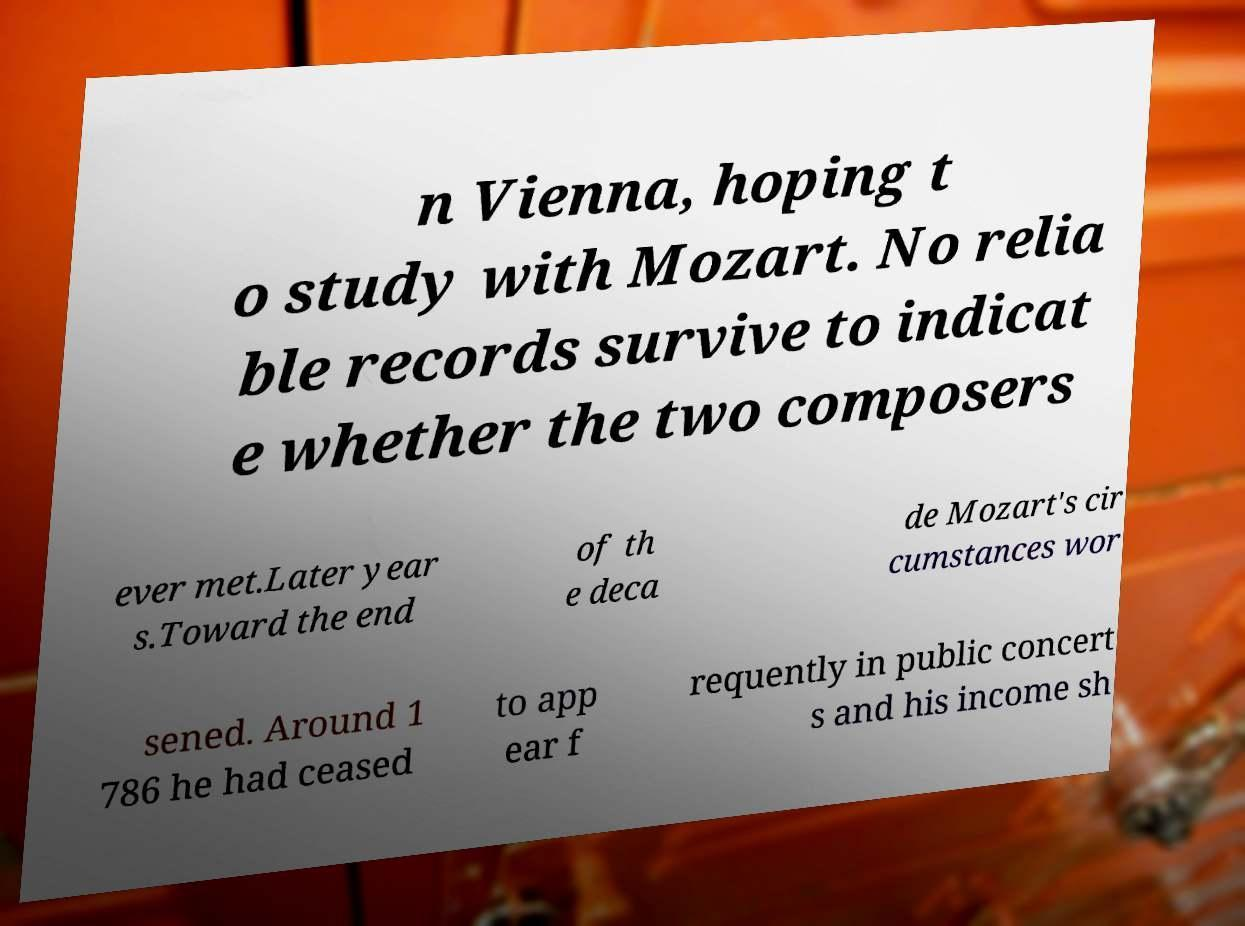Could you extract and type out the text from this image? n Vienna, hoping t o study with Mozart. No relia ble records survive to indicat e whether the two composers ever met.Later year s.Toward the end of th e deca de Mozart's cir cumstances wor sened. Around 1 786 he had ceased to app ear f requently in public concert s and his income sh 